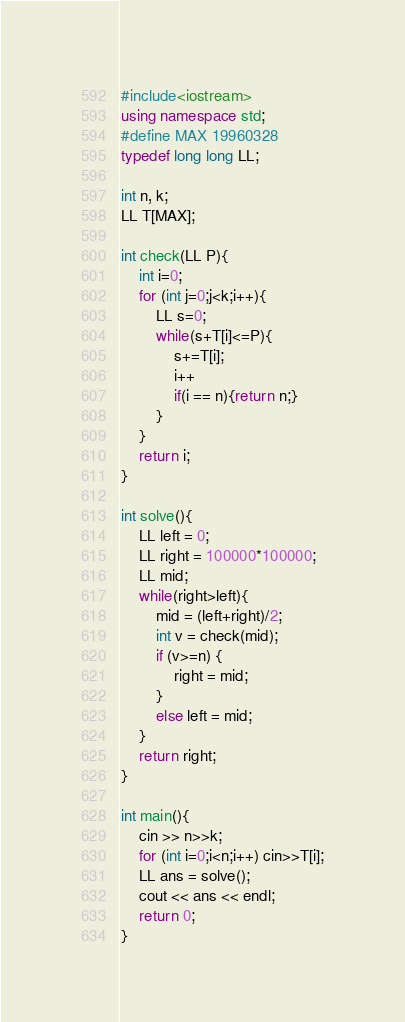<code> <loc_0><loc_0><loc_500><loc_500><_C++_>#include<iostream>
using namespace std;
#define MAX 19960328
typedef long long LL;

int n, k;
LL T[MAX];

int check(LL P){
    int i=0;
    for (int j=0;j<k;i++){
        LL s=0;
        while(s+T[i]<=P){
            s+=T[i];
            i++
            if(i == n){return n;}
        }
    }
    return i;
}

int solve(){
    LL left = 0;
    LL right = 100000*100000;
    LL mid;
    while(right>left){
        mid = (left+right)/2;
        int v = check(mid);
        if (v>=n) {
            right = mid;
        }
        else left = mid;
    }
    return right;
}

int main(){
    cin >> n>>k;
    for (int i=0;i<n;i++) cin>>T[i];
    LL ans = solve();
    cout << ans << endl;
    return 0;
}</code> 